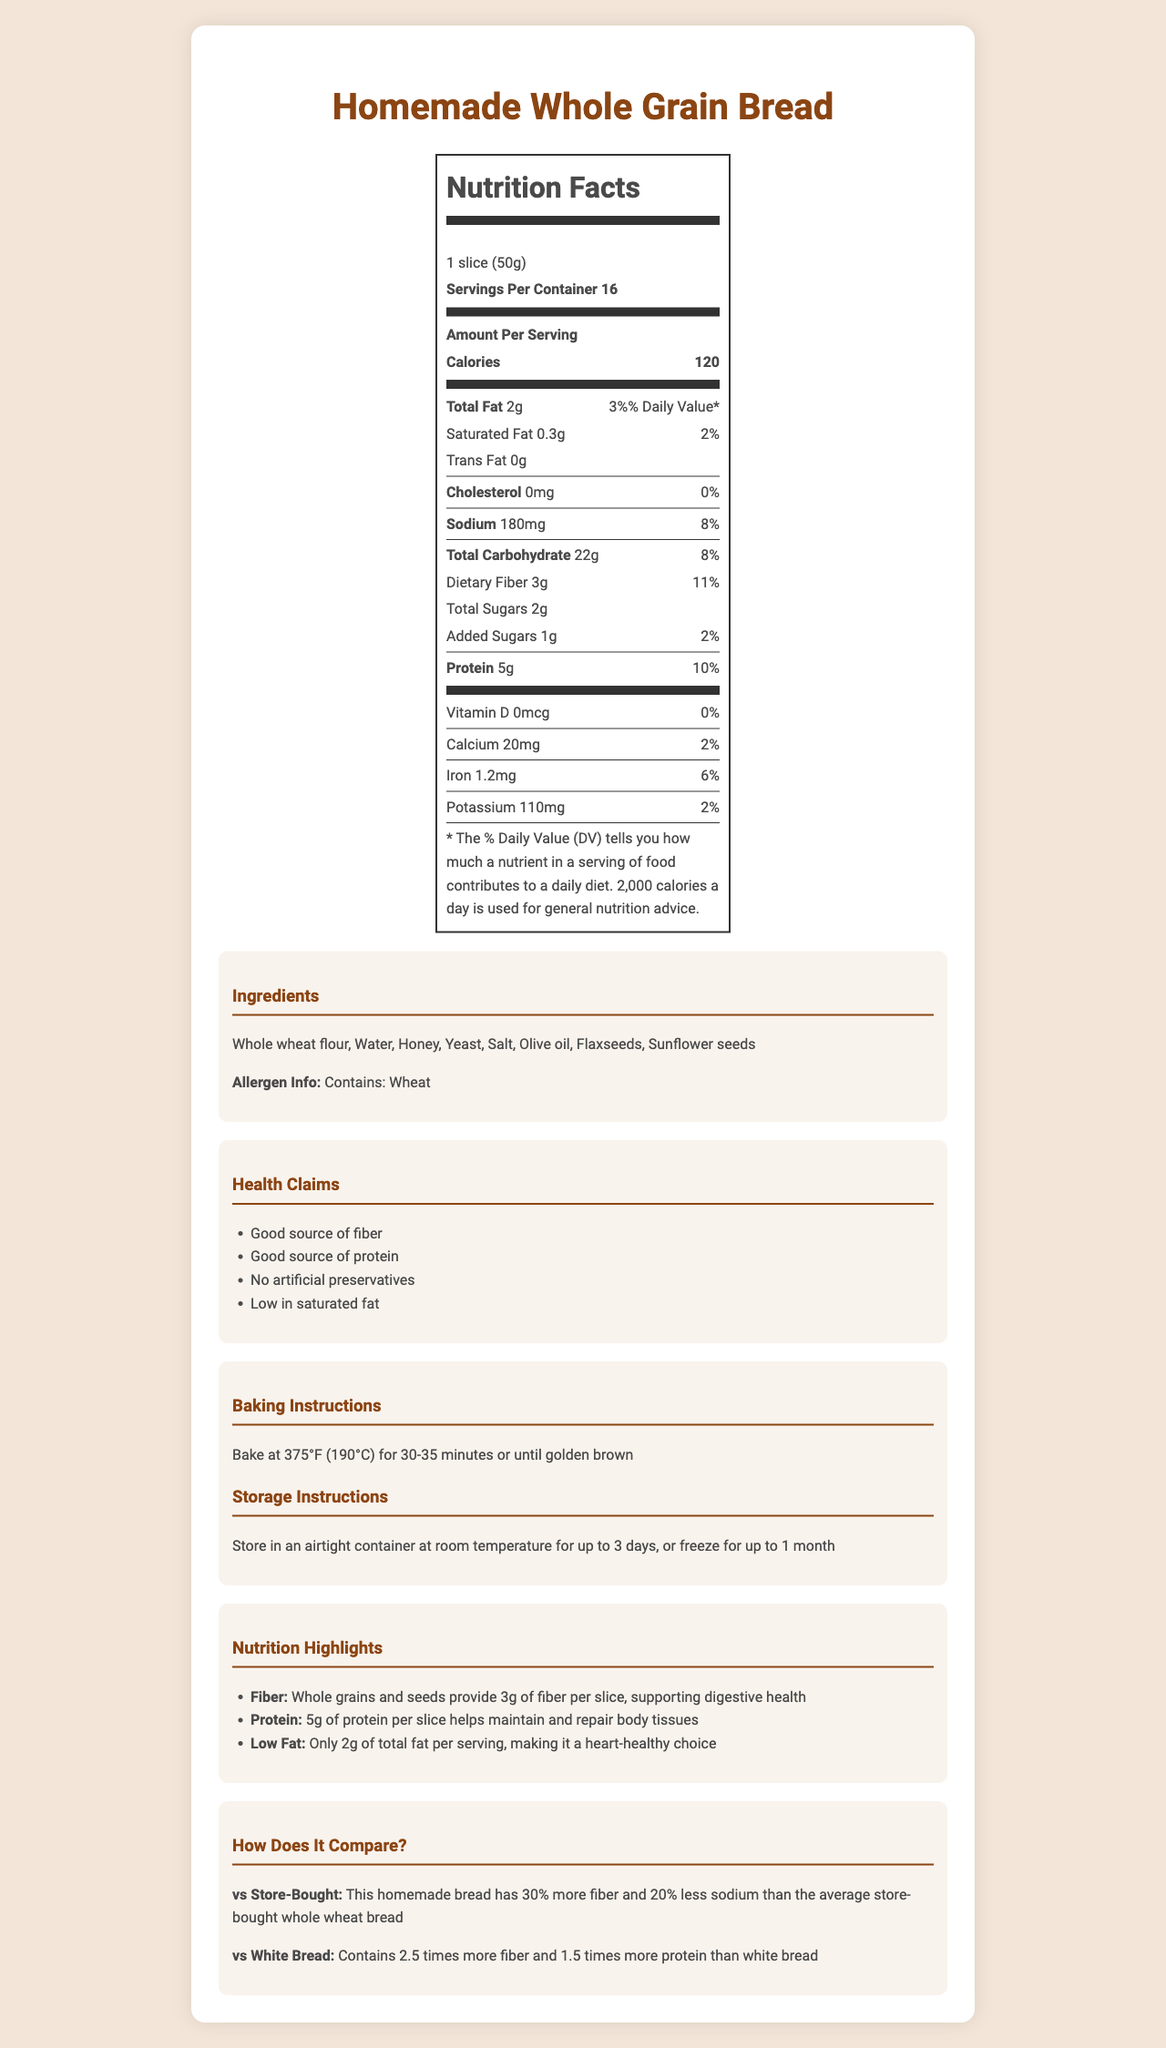what is the serving size? The serving size is provided directly under the product name as "1 slice (50g)".
Answer: 1 slice (50g) how many grams of fiber are in one serving? The amount of dietary fiber per serving is listed as 3g.
Answer: 3g how much protein is in a serving of this bread? The nutrition label specifies that each serving contains 5g of protein.
Answer: 5g what is the daily value percentage for dietary fiber? The daily value percentage for dietary fiber is listed as 11% next to the amount per serving.
Answer: 11% what are the main ingredients in the bread? The ingredients are listed in the ingredients section as "Whole wheat flour, Water, Honey, Yeast, Salt, Olive oil, Flaxseeds, Sunflower seeds".
Answer: Whole wheat flour, Water, Honey, Yeast, Salt, Olive oil, Flaxseeds, Sunflower seeds which vitamin is completely absent in this bread? A. Vitamin C B. Vitamin A C. Vitamin D D. Vitamin E The nutrition label shows that Vitamin D amount is 0mcg and the daily value is 0%.
Answer: C how much sodium does one serving contain? A. 180mg B. 110mg C. 20mg D. 0mg The nutrition label lists sodium content per serving as 180mg.
Answer: A this bread contains no artificial preservatives. True or False? The health claims include "No artificial preservatives."
Answer: True summarize the main health benefits of this bread. The health claims and nutrition highlights state that the bread is a good source of fiber and protein, has low saturated fat, supports digestive health, helps maintain and repair body tissues, and is a heart-healthy choice.
Answer: High in fiber and protein, low in saturated fat, supports digestive health, maintains and repairs body tissues, heart-healthy choice. does this bread contain any calcium? The nutrition label specifies that each serving contains 20mg of calcium.
Answer: Yes how many calories are in one slice of this bread? The amount of calories per serving is listed as 120.
Answer: 120 what is the total carbohydrate content per serving? The nutrition label shows that the total carbohydrate content per serving is 22g.
Answer: 22g compare the fiber content of this bread to that of white bread. The comparisons section states that this bread contains 2.5 times more fiber than white bread.
Answer: Contains 2.5 times more fiber than white bread what are the storage instructions for this bread after baking? The storage instructions section provides this information explicitly.
Answer: Store in an airtight container at room temperature for up to 3 days, or freeze for up to 1 month how should the bread be baked? The baking instructions section provides the necessary temperature and duration.
Answer: Bake at 375°F (190°C) for 30-35 minutes or until golden brown what percentage of the daily recommended sodium intake does one serving of this bread cover? The daily value for sodium per serving is listed as 8%.
Answer: 8% does the bread contain any allergens? The allergen information specifies that the bread contains wheat.
Answer: Yes, it contains wheat can I determine the amount of Vitamin C in this bread? The nutrition label does not provide any information about Vitamin C content.
Answer: Cannot be determined 